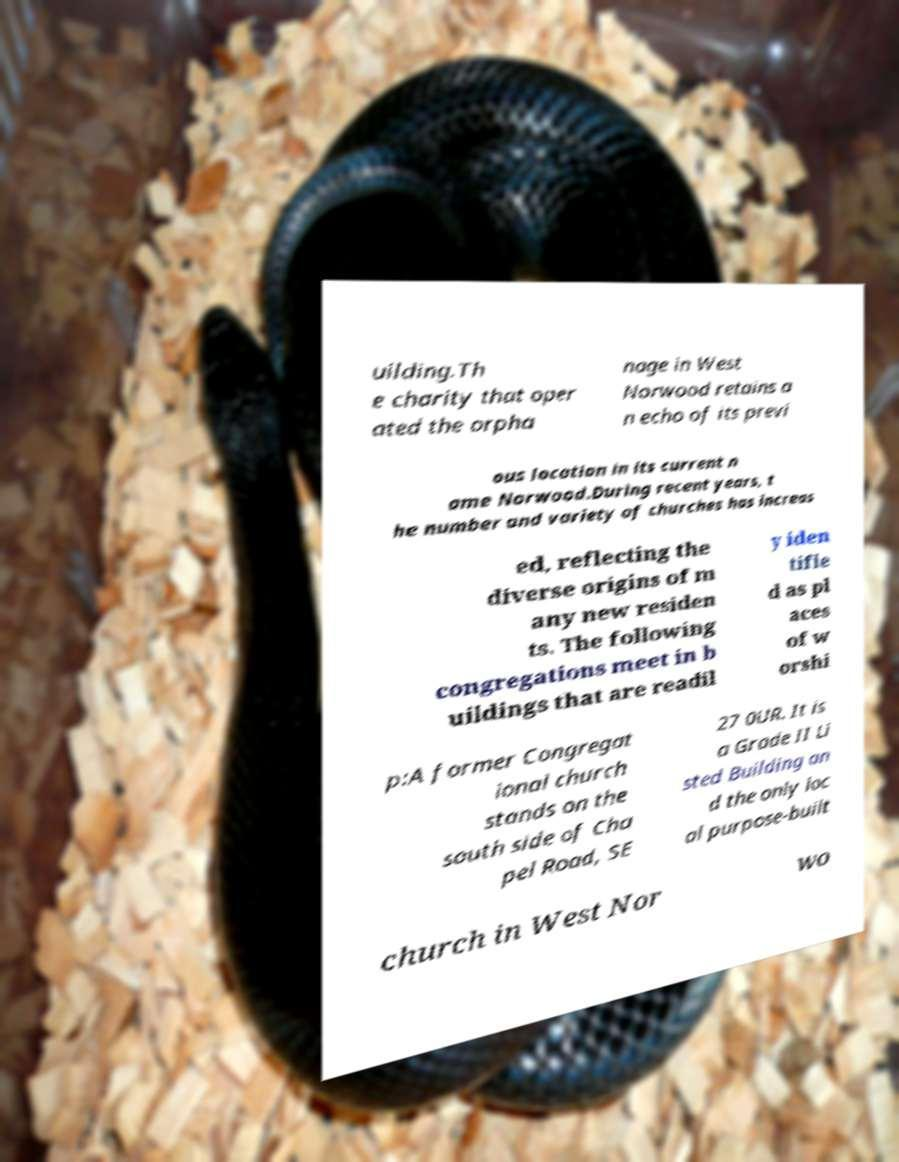Could you assist in decoding the text presented in this image and type it out clearly? uilding.Th e charity that oper ated the orpha nage in West Norwood retains a n echo of its previ ous location in its current n ame Norwood.During recent years, t he number and variety of churches has increas ed, reflecting the diverse origins of m any new residen ts. The following congregations meet in b uildings that are readil y iden tifie d as pl aces of w orshi p:A former Congregat ional church stands on the south side of Cha pel Road, SE 27 0UR. It is a Grade II Li sted Building an d the only loc al purpose-built church in West Nor wo 